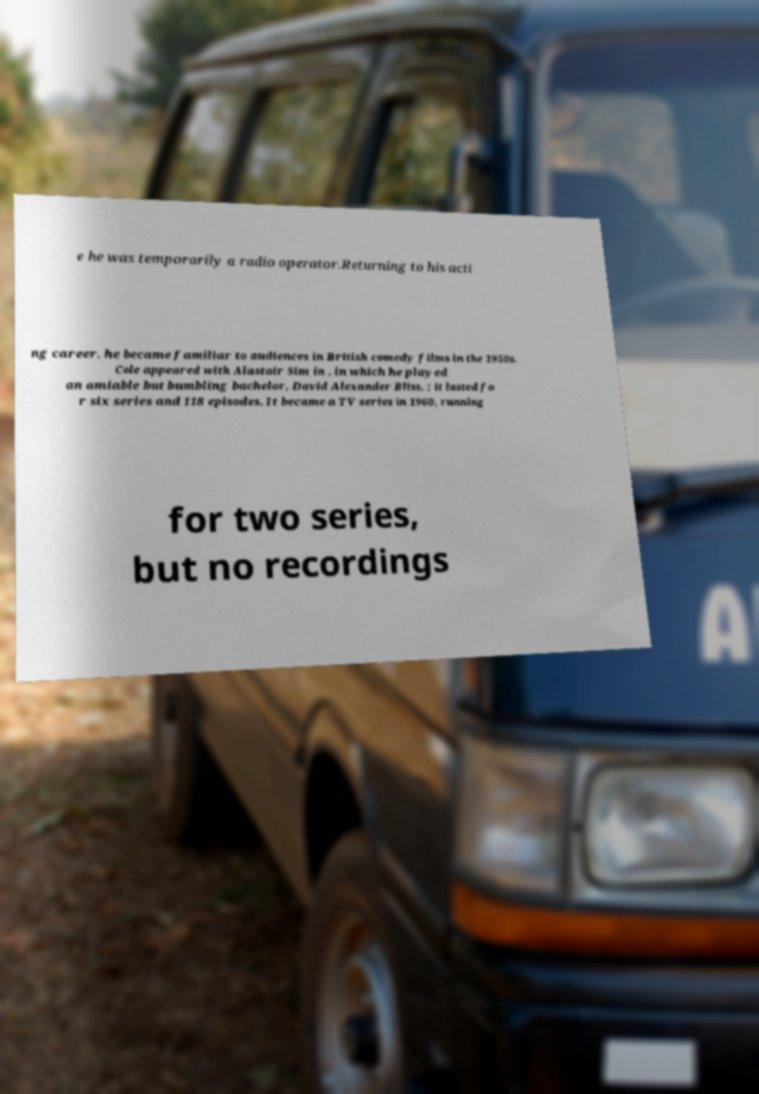Can you accurately transcribe the text from the provided image for me? e he was temporarily a radio operator.Returning to his acti ng career, he became familiar to audiences in British comedy films in the 1950s. Cole appeared with Alastair Sim in , in which he played an amiable but bumbling bachelor, David Alexander Bliss, ; it lasted fo r six series and 118 episodes. It became a TV series in 1960, running for two series, but no recordings 